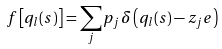<formula> <loc_0><loc_0><loc_500><loc_500>f \left [ q _ { l } ( s ) \right ] = \sum _ { j } p _ { j } \, \delta \left ( q _ { l } ( s ) - z _ { j } e \right )</formula> 